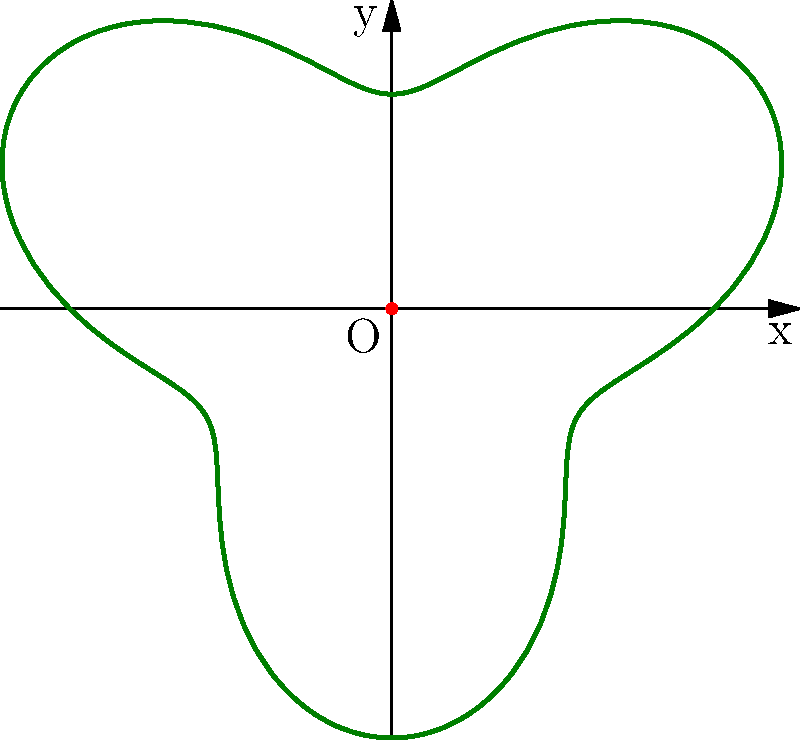A rancher's property is enclosed by a fence line described by the polar equation $r = 3 + \sin(3\theta)$, where $r$ is measured in miles. As a writer seeking inspiration for your novel, you want to calculate the maximum distance from the center of the property (O) to any point on the fence. What is this maximum distance in miles? To find the maximum distance from the center to any point on the fence, we need to maximize the function $r = 3 + \sin(3\theta)$.

Step 1: The maximum value of sine is 1, which occurs when its argument is $\frac{\pi}{2}$ (or odd multiples of it).

Step 2: We need to solve $3\theta = \frac{\pi}{2}$ (or odd multiples of it).
$\theta = \frac{\pi}{6}, \frac{\pi}{2}, \frac{5\pi}{6}, ...$

Step 3: The maximum value of $r$ occurs when $\sin(3\theta) = 1$.

Step 4: Substitute this into the original equation:
$r_{max} = 3 + 1 = 4$

Therefore, the maximum distance from the center of the property to any point on the fence is 4 miles.
Answer: 4 miles 